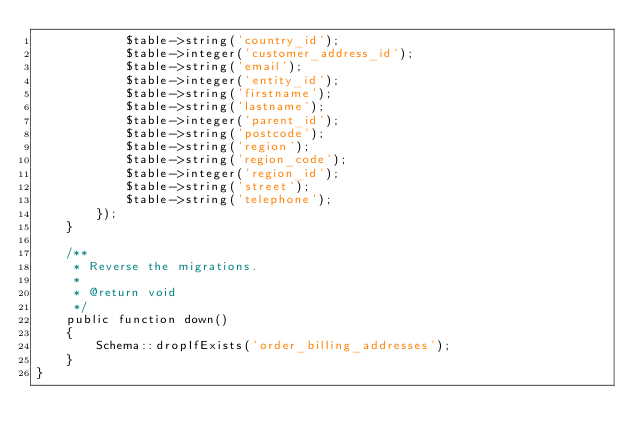Convert code to text. <code><loc_0><loc_0><loc_500><loc_500><_PHP_>            $table->string('country_id');
            $table->integer('customer_address_id');
            $table->string('email');
            $table->integer('entity_id');
            $table->string('firstname');
            $table->string('lastname');
            $table->integer('parent_id');
            $table->string('postcode');
            $table->string('region');
            $table->string('region_code');
            $table->integer('region_id');
            $table->string('street');
            $table->string('telephone');
        });
    }

    /**
     * Reverse the migrations.
     *
     * @return void
     */
    public function down()
    {
        Schema::dropIfExists('order_billing_addresses');
    }
}
</code> 